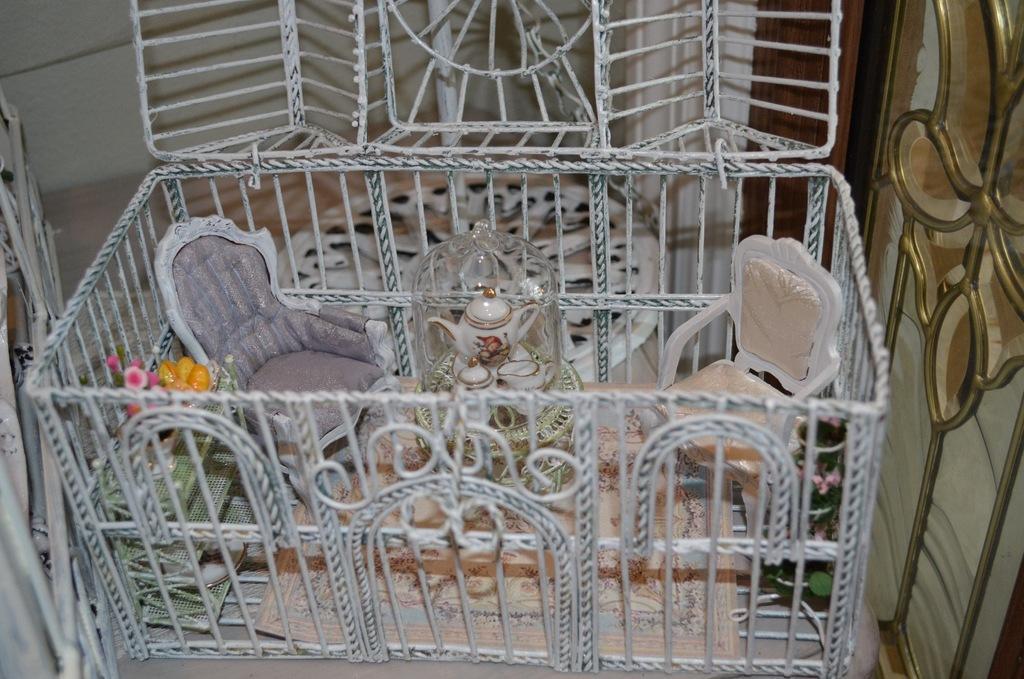Describe this image in one or two sentences. In this picture I can see scale model toys like chairs, table, mat , tea pots and a cup with a lid, racks, plate, flower vase and fruits in a square shaped cage, and in the background there are some other items. 